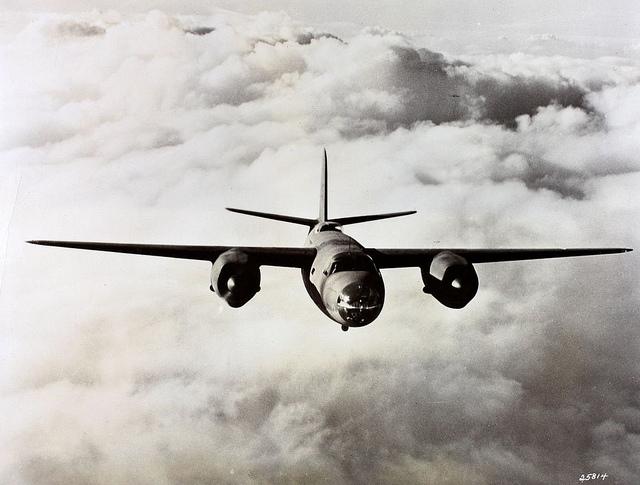What is behind the plane?
Quick response, please. Clouds. Is this plane above the clouds?
Short answer required. Yes. Is this a commercial plane?
Quick response, please. No. 